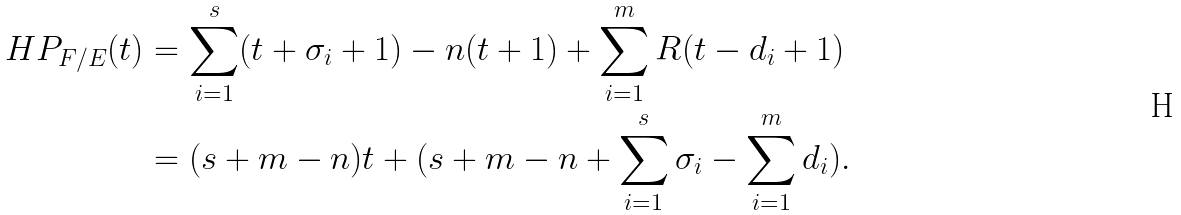<formula> <loc_0><loc_0><loc_500><loc_500>H P _ { F / E } ( t ) & = \sum _ { i = 1 } ^ { s } ( t + \sigma _ { i } + 1 ) - n ( t + 1 ) + \sum _ { i = 1 } ^ { m } R ( t - d _ { i } + 1 ) \\ & = ( s + m - n ) t + ( s + m - n + \sum _ { i = 1 } ^ { s } \sigma _ { i } - \sum _ { i = 1 } ^ { m } d _ { i } ) .</formula> 